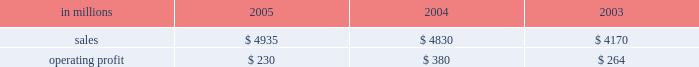Entering 2006 , earnings in the first quarter are ex- pected to improve compared with the 2005 fourth quar- ter due principally to higher average price realizations , reflecting announced price increases .
Product demand for the first quarter should be seasonally slow , but is ex- pected to strengthen as the year progresses , supported by continued economic growth in north america , asia and eastern europe .
Average prices should also improve in 2006 as price increases announced in late 2005 and early 2006 for uncoated freesheet paper and pulp con- tinue to be realized .
Operating rates are expected to improve as a result of industry-wide capacity reductions in 2005 .
Although energy and raw material costs remain high , there has been some decline in both natural gas and delivered wood costs , with further moderation ex- pected later in 2006 .
We will continue to focus on fur- ther improvements in our global manufacturing operations , implementation of supply chain enhance- ments and reductions in overhead costs during 2006 .
Industrial packaging demand for industrial packaging products is closely correlated with non-durable industrial goods production in the united states , as well as with demand for proc- essed foods , poultry , meat and agricultural products .
In addition to prices and volumes , major factors affecting the profitability of industrial packaging are raw material and energy costs , manufacturing efficiency and product industrial packaging 2019s net sales for 2005 increased 2% ( 2 % ) compared with 2004 , and were 18% ( 18 % ) higher than in 2003 , reflecting the inclusion of international paper distribution limited ( formerly international paper pacific millennium limited ) beginning in august 2005 .
Operating profits in 2005 were 39% ( 39 % ) lower than in 2004 and 13% ( 13 % ) lower than in 2003 .
Sales volume increases ( $ 24 million ) , improved price realizations ( $ 66 million ) , and strong mill operating performance ( $ 27 million ) were not enough to offset the effects of increased raw material costs ( $ 103 million ) , higher market related downtime costs ( $ 50 million ) , higher converting operating costs ( $ 22 million ) , and unfavorable mix and other costs ( $ 67 million ) .
Additionally , the may 2005 sale of our industrial papers business resulted in a $ 25 million lower earnings contribution from this business in 2005 .
The segment took 370000 tons of downtime in 2005 , including 230000 tons of lack-of-order downtime to balance internal supply with customer demand , com- pared to a total of 170000 tons in 2004 , which included 5000 tons of lack-of-order downtime .
Industrial packaging in millions 2005 2004 2003 .
Containerboard 2019s net sales totaled $ 895 million in 2005 , $ 951 million in 2004 and $ 815 million in 2003 .
Soft market conditions and declining customer demand at the end of the first quarter led to lower average sales prices during the second and third quarters .
Beginning in the fourth quarter , prices recovered as a result of in- creased customer demand and a rationalization of sup- ply .
Full year sales volumes trailed 2004 levels early in the year , reflecting the weak market conditions in the first half of 2005 .
However , volumes rebounded in the second half of the year , and finished the year ahead of 2004 levels .
Operating profits decreased 38% ( 38 % ) from 2004 , but were flat with 2003 .
The favorable impacts of in- creased sales volumes , higher average sales prices and improved mill operating performance were not enough to offset the impact of higher wood , energy and other raw material costs and increased lack-of-order down- time .
Implementation of the new supply chain operating model in our containerboard mills during 2005 resulted in increased operating efficiency and cost savings .
Specialty papers in 2005 included the kraft paper business for the full year and the industrial papers busi- ness for five months prior to its sale in may 2005 .
Net sales totaled $ 468 million in 2005 , $ 723 million in 2004 and $ 690 million in 2003 .
Operating profits in 2005 were down 23% ( 23 % ) compared with 2004 and 54% ( 54 % ) com- pared with 2003 , reflecting the lower contribution from industrial papers .
U.s .
Converting operations net sales for 2005 were $ 2.6 billion compared with $ 2.3 billion in 2004 and $ 1.9 billion in 2003 .
Sales volumes were up 10% ( 10 % ) in 2005 compared with 2004 , mainly due to the acquisition of box usa in july 2004 .
Average sales prices in 2005 began the year above 2004 levels , but softened in the second half of the year .
Operating profits in 2005 de- creased 46% ( 46 % ) and 4% ( 4 % ) from 2004 and 2003 levels , re- spectively , primarily due to increased linerboard , freight and energy costs .
European container sales for 2005 were $ 883 mil- lion compared with $ 865 million in 2004 and $ 801 mil- lion in 2003 .
Operating profits declined 19% ( 19 % ) and 13% ( 13 % ) compared with 2004 and 2003 , respectively .
The in- crease in sales in 2005 reflected a slight increase in de- mand over 2004 , but this was not sufficient to offset the negative earnings effect of increased operating costs , unfavorable foreign exchange rates and a reduction in average sales prices .
The moroccan box plant acquis- ition , which was completed in october 2005 , favorably impacted fourth-quarter results .
Industrial packaging 2019s sales in 2005 included $ 104 million from international paper distribution limited , our asian box and containerboard business , subsequent to the acquisition of an additional 50% ( 50 % ) interest in au- gust 2005. .
Containerboards net sales represented what percentage of industrial packaging sales in 2004? 
Computations: (951 / 4830)
Answer: 0.19689. 